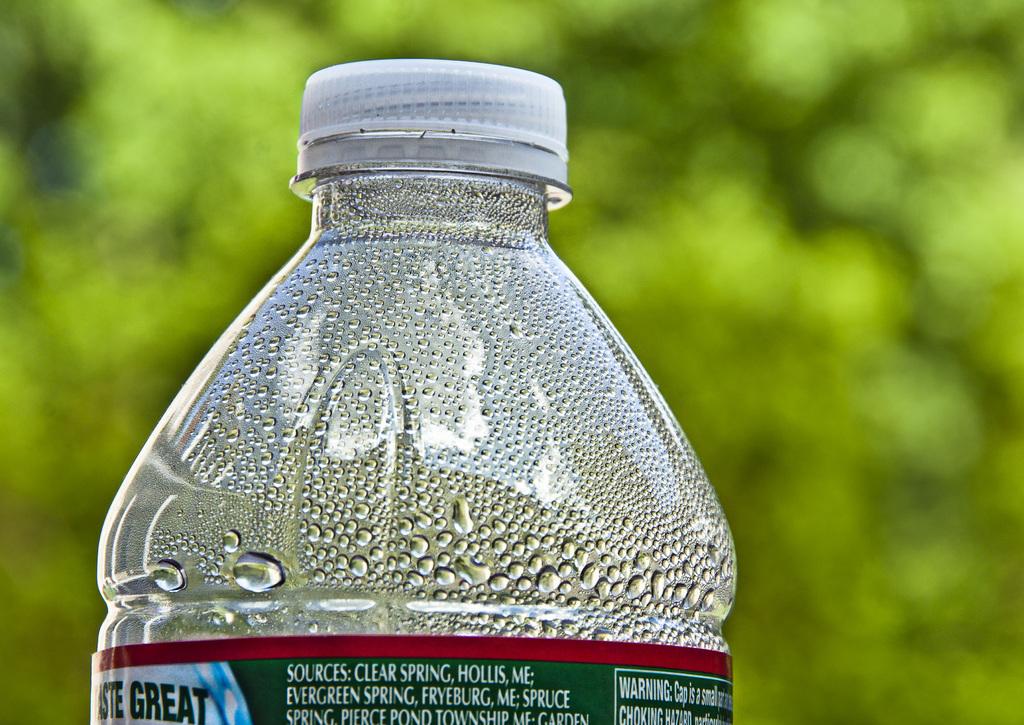What is in the bottle?
Make the answer very short. Water. What is the source of water?
Your answer should be compact. Answering does not require reading text in the image. 